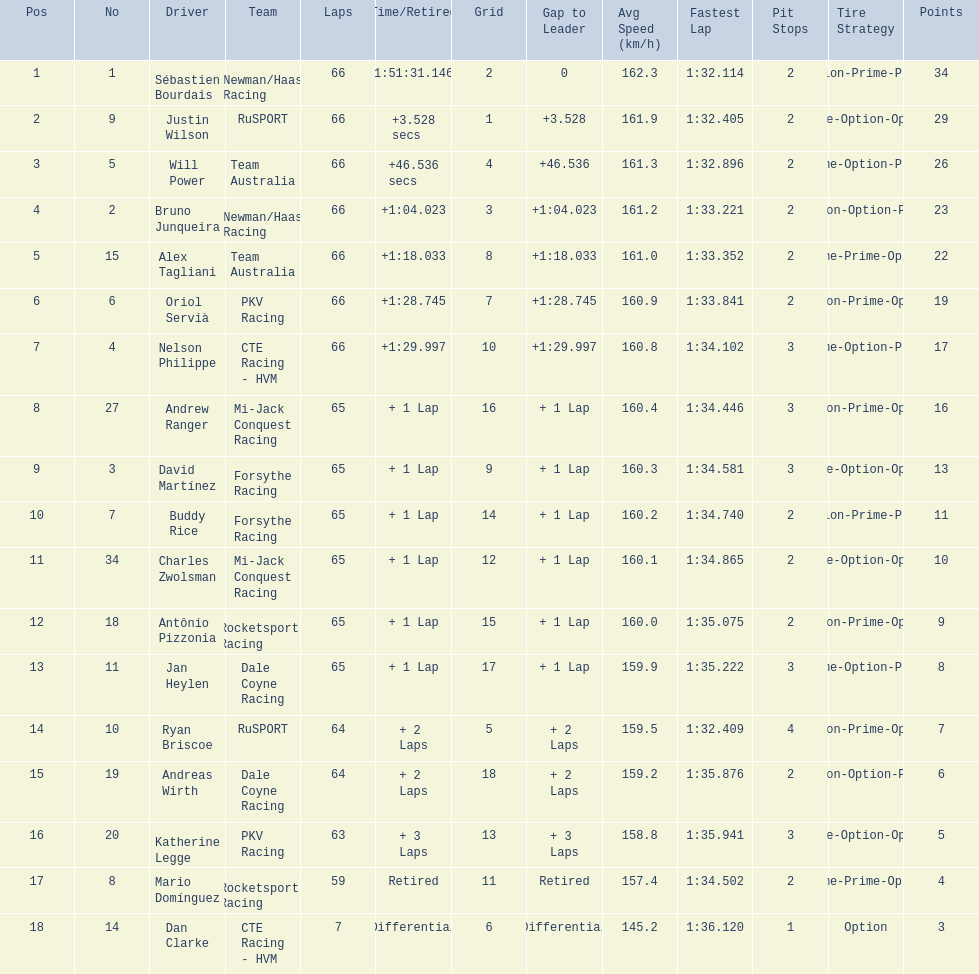Which teams participated in the 2006 gran premio telmex? Newman/Haas Racing, RuSPORT, Team Australia, Newman/Haas Racing, Team Australia, PKV Racing, CTE Racing - HVM, Mi-Jack Conquest Racing, Forsythe Racing, Forsythe Racing, Mi-Jack Conquest Racing, Rocketsports Racing, Dale Coyne Racing, RuSPORT, Dale Coyne Racing, PKV Racing, Rocketsports Racing, CTE Racing - HVM. Who were the drivers of these teams? Sébastien Bourdais, Justin Wilson, Will Power, Bruno Junqueira, Alex Tagliani, Oriol Servià, Nelson Philippe, Andrew Ranger, David Martínez, Buddy Rice, Charles Zwolsman, Antônio Pizzonia, Jan Heylen, Ryan Briscoe, Andreas Wirth, Katherine Legge, Mario Domínguez, Dan Clarke. Which driver finished last? Dan Clarke. 